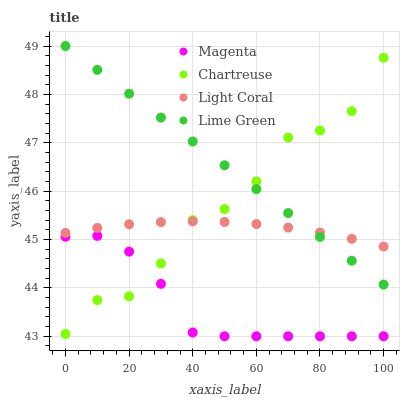Does Magenta have the minimum area under the curve?
Answer yes or no. Yes. Does Lime Green have the maximum area under the curve?
Answer yes or no. Yes. Does Lime Green have the minimum area under the curve?
Answer yes or no. No. Does Magenta have the maximum area under the curve?
Answer yes or no. No. Is Lime Green the smoothest?
Answer yes or no. Yes. Is Chartreuse the roughest?
Answer yes or no. Yes. Is Magenta the smoothest?
Answer yes or no. No. Is Magenta the roughest?
Answer yes or no. No. Does Magenta have the lowest value?
Answer yes or no. Yes. Does Lime Green have the lowest value?
Answer yes or no. No. Does Lime Green have the highest value?
Answer yes or no. Yes. Does Magenta have the highest value?
Answer yes or no. No. Is Magenta less than Light Coral?
Answer yes or no. Yes. Is Light Coral greater than Magenta?
Answer yes or no. Yes. Does Light Coral intersect Lime Green?
Answer yes or no. Yes. Is Light Coral less than Lime Green?
Answer yes or no. No. Is Light Coral greater than Lime Green?
Answer yes or no. No. Does Magenta intersect Light Coral?
Answer yes or no. No. 